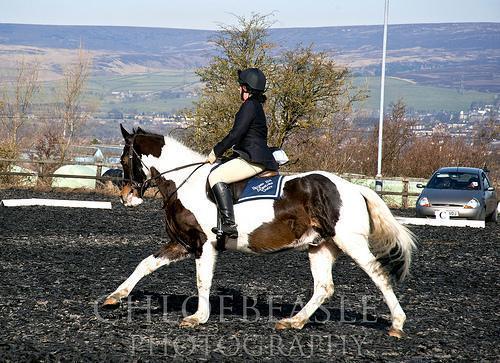How many horses are there?
Give a very brief answer. 1. How many cars are seen?
Give a very brief answer. 1. 